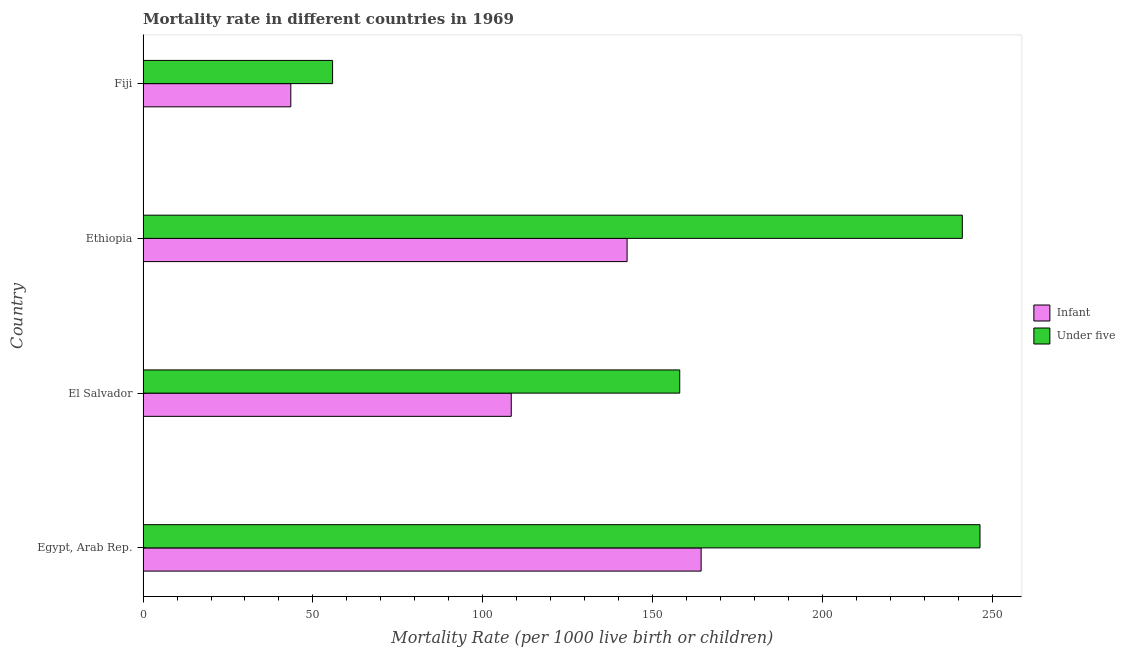Are the number of bars per tick equal to the number of legend labels?
Offer a very short reply. Yes. Are the number of bars on each tick of the Y-axis equal?
Offer a terse response. Yes. What is the label of the 1st group of bars from the top?
Your answer should be compact. Fiji. In how many cases, is the number of bars for a given country not equal to the number of legend labels?
Provide a short and direct response. 0. What is the under-5 mortality rate in Egypt, Arab Rep.?
Your answer should be compact. 246.4. Across all countries, what is the maximum under-5 mortality rate?
Make the answer very short. 246.4. Across all countries, what is the minimum infant mortality rate?
Your answer should be very brief. 43.5. In which country was the infant mortality rate maximum?
Provide a short and direct response. Egypt, Arab Rep. In which country was the infant mortality rate minimum?
Offer a terse response. Fiji. What is the total under-5 mortality rate in the graph?
Ensure brevity in your answer.  701.4. What is the difference between the infant mortality rate in El Salvador and that in Ethiopia?
Keep it short and to the point. -34.1. What is the difference between the under-5 mortality rate in Ethiopia and the infant mortality rate in Egypt, Arab Rep.?
Offer a terse response. 76.9. What is the average under-5 mortality rate per country?
Offer a terse response. 175.35. What is the difference between the under-5 mortality rate and infant mortality rate in El Salvador?
Give a very brief answer. 49.6. In how many countries, is the under-5 mortality rate greater than 130 ?
Provide a short and direct response. 3. What is the ratio of the under-5 mortality rate in Egypt, Arab Rep. to that in El Salvador?
Offer a terse response. 1.56. What is the difference between the highest and the second highest under-5 mortality rate?
Ensure brevity in your answer.  5.2. What is the difference between the highest and the lowest under-5 mortality rate?
Keep it short and to the point. 190.6. Is the sum of the under-5 mortality rate in El Salvador and Ethiopia greater than the maximum infant mortality rate across all countries?
Give a very brief answer. Yes. What does the 2nd bar from the top in El Salvador represents?
Provide a short and direct response. Infant. What does the 1st bar from the bottom in El Salvador represents?
Offer a very short reply. Infant. How many bars are there?
Your response must be concise. 8. Are all the bars in the graph horizontal?
Your answer should be very brief. Yes. How many countries are there in the graph?
Provide a succinct answer. 4. What is the difference between two consecutive major ticks on the X-axis?
Your response must be concise. 50. Are the values on the major ticks of X-axis written in scientific E-notation?
Give a very brief answer. No. Where does the legend appear in the graph?
Offer a terse response. Center right. How are the legend labels stacked?
Your answer should be compact. Vertical. What is the title of the graph?
Offer a very short reply. Mortality rate in different countries in 1969. What is the label or title of the X-axis?
Ensure brevity in your answer.  Mortality Rate (per 1000 live birth or children). What is the label or title of the Y-axis?
Provide a short and direct response. Country. What is the Mortality Rate (per 1000 live birth or children) in Infant in Egypt, Arab Rep.?
Provide a short and direct response. 164.3. What is the Mortality Rate (per 1000 live birth or children) in Under five in Egypt, Arab Rep.?
Give a very brief answer. 246.4. What is the Mortality Rate (per 1000 live birth or children) in Infant in El Salvador?
Make the answer very short. 108.4. What is the Mortality Rate (per 1000 live birth or children) of Under five in El Salvador?
Make the answer very short. 158. What is the Mortality Rate (per 1000 live birth or children) of Infant in Ethiopia?
Offer a very short reply. 142.5. What is the Mortality Rate (per 1000 live birth or children) in Under five in Ethiopia?
Your answer should be very brief. 241.2. What is the Mortality Rate (per 1000 live birth or children) of Infant in Fiji?
Give a very brief answer. 43.5. What is the Mortality Rate (per 1000 live birth or children) in Under five in Fiji?
Provide a succinct answer. 55.8. Across all countries, what is the maximum Mortality Rate (per 1000 live birth or children) of Infant?
Your answer should be very brief. 164.3. Across all countries, what is the maximum Mortality Rate (per 1000 live birth or children) in Under five?
Provide a succinct answer. 246.4. Across all countries, what is the minimum Mortality Rate (per 1000 live birth or children) of Infant?
Offer a very short reply. 43.5. Across all countries, what is the minimum Mortality Rate (per 1000 live birth or children) of Under five?
Provide a short and direct response. 55.8. What is the total Mortality Rate (per 1000 live birth or children) of Infant in the graph?
Provide a succinct answer. 458.7. What is the total Mortality Rate (per 1000 live birth or children) of Under five in the graph?
Your answer should be compact. 701.4. What is the difference between the Mortality Rate (per 1000 live birth or children) of Infant in Egypt, Arab Rep. and that in El Salvador?
Provide a succinct answer. 55.9. What is the difference between the Mortality Rate (per 1000 live birth or children) in Under five in Egypt, Arab Rep. and that in El Salvador?
Offer a very short reply. 88.4. What is the difference between the Mortality Rate (per 1000 live birth or children) in Infant in Egypt, Arab Rep. and that in Ethiopia?
Provide a short and direct response. 21.8. What is the difference between the Mortality Rate (per 1000 live birth or children) in Under five in Egypt, Arab Rep. and that in Ethiopia?
Keep it short and to the point. 5.2. What is the difference between the Mortality Rate (per 1000 live birth or children) of Infant in Egypt, Arab Rep. and that in Fiji?
Offer a terse response. 120.8. What is the difference between the Mortality Rate (per 1000 live birth or children) in Under five in Egypt, Arab Rep. and that in Fiji?
Provide a short and direct response. 190.6. What is the difference between the Mortality Rate (per 1000 live birth or children) of Infant in El Salvador and that in Ethiopia?
Your response must be concise. -34.1. What is the difference between the Mortality Rate (per 1000 live birth or children) in Under five in El Salvador and that in Ethiopia?
Your response must be concise. -83.2. What is the difference between the Mortality Rate (per 1000 live birth or children) in Infant in El Salvador and that in Fiji?
Provide a succinct answer. 64.9. What is the difference between the Mortality Rate (per 1000 live birth or children) of Under five in El Salvador and that in Fiji?
Ensure brevity in your answer.  102.2. What is the difference between the Mortality Rate (per 1000 live birth or children) of Under five in Ethiopia and that in Fiji?
Your answer should be very brief. 185.4. What is the difference between the Mortality Rate (per 1000 live birth or children) in Infant in Egypt, Arab Rep. and the Mortality Rate (per 1000 live birth or children) in Under five in Ethiopia?
Offer a very short reply. -76.9. What is the difference between the Mortality Rate (per 1000 live birth or children) in Infant in Egypt, Arab Rep. and the Mortality Rate (per 1000 live birth or children) in Under five in Fiji?
Ensure brevity in your answer.  108.5. What is the difference between the Mortality Rate (per 1000 live birth or children) of Infant in El Salvador and the Mortality Rate (per 1000 live birth or children) of Under five in Ethiopia?
Give a very brief answer. -132.8. What is the difference between the Mortality Rate (per 1000 live birth or children) of Infant in El Salvador and the Mortality Rate (per 1000 live birth or children) of Under five in Fiji?
Your answer should be very brief. 52.6. What is the difference between the Mortality Rate (per 1000 live birth or children) of Infant in Ethiopia and the Mortality Rate (per 1000 live birth or children) of Under five in Fiji?
Offer a terse response. 86.7. What is the average Mortality Rate (per 1000 live birth or children) of Infant per country?
Your answer should be very brief. 114.67. What is the average Mortality Rate (per 1000 live birth or children) in Under five per country?
Offer a terse response. 175.35. What is the difference between the Mortality Rate (per 1000 live birth or children) in Infant and Mortality Rate (per 1000 live birth or children) in Under five in Egypt, Arab Rep.?
Make the answer very short. -82.1. What is the difference between the Mortality Rate (per 1000 live birth or children) of Infant and Mortality Rate (per 1000 live birth or children) of Under five in El Salvador?
Give a very brief answer. -49.6. What is the difference between the Mortality Rate (per 1000 live birth or children) of Infant and Mortality Rate (per 1000 live birth or children) of Under five in Ethiopia?
Provide a succinct answer. -98.7. What is the difference between the Mortality Rate (per 1000 live birth or children) in Infant and Mortality Rate (per 1000 live birth or children) in Under five in Fiji?
Your response must be concise. -12.3. What is the ratio of the Mortality Rate (per 1000 live birth or children) of Infant in Egypt, Arab Rep. to that in El Salvador?
Your answer should be very brief. 1.52. What is the ratio of the Mortality Rate (per 1000 live birth or children) of Under five in Egypt, Arab Rep. to that in El Salvador?
Keep it short and to the point. 1.56. What is the ratio of the Mortality Rate (per 1000 live birth or children) in Infant in Egypt, Arab Rep. to that in Ethiopia?
Offer a very short reply. 1.15. What is the ratio of the Mortality Rate (per 1000 live birth or children) of Under five in Egypt, Arab Rep. to that in Ethiopia?
Your answer should be compact. 1.02. What is the ratio of the Mortality Rate (per 1000 live birth or children) of Infant in Egypt, Arab Rep. to that in Fiji?
Provide a succinct answer. 3.78. What is the ratio of the Mortality Rate (per 1000 live birth or children) in Under five in Egypt, Arab Rep. to that in Fiji?
Your response must be concise. 4.42. What is the ratio of the Mortality Rate (per 1000 live birth or children) in Infant in El Salvador to that in Ethiopia?
Make the answer very short. 0.76. What is the ratio of the Mortality Rate (per 1000 live birth or children) of Under five in El Salvador to that in Ethiopia?
Your answer should be compact. 0.66. What is the ratio of the Mortality Rate (per 1000 live birth or children) in Infant in El Salvador to that in Fiji?
Offer a terse response. 2.49. What is the ratio of the Mortality Rate (per 1000 live birth or children) of Under five in El Salvador to that in Fiji?
Provide a short and direct response. 2.83. What is the ratio of the Mortality Rate (per 1000 live birth or children) in Infant in Ethiopia to that in Fiji?
Provide a succinct answer. 3.28. What is the ratio of the Mortality Rate (per 1000 live birth or children) in Under five in Ethiopia to that in Fiji?
Ensure brevity in your answer.  4.32. What is the difference between the highest and the second highest Mortality Rate (per 1000 live birth or children) in Infant?
Your answer should be very brief. 21.8. What is the difference between the highest and the lowest Mortality Rate (per 1000 live birth or children) in Infant?
Keep it short and to the point. 120.8. What is the difference between the highest and the lowest Mortality Rate (per 1000 live birth or children) in Under five?
Keep it short and to the point. 190.6. 